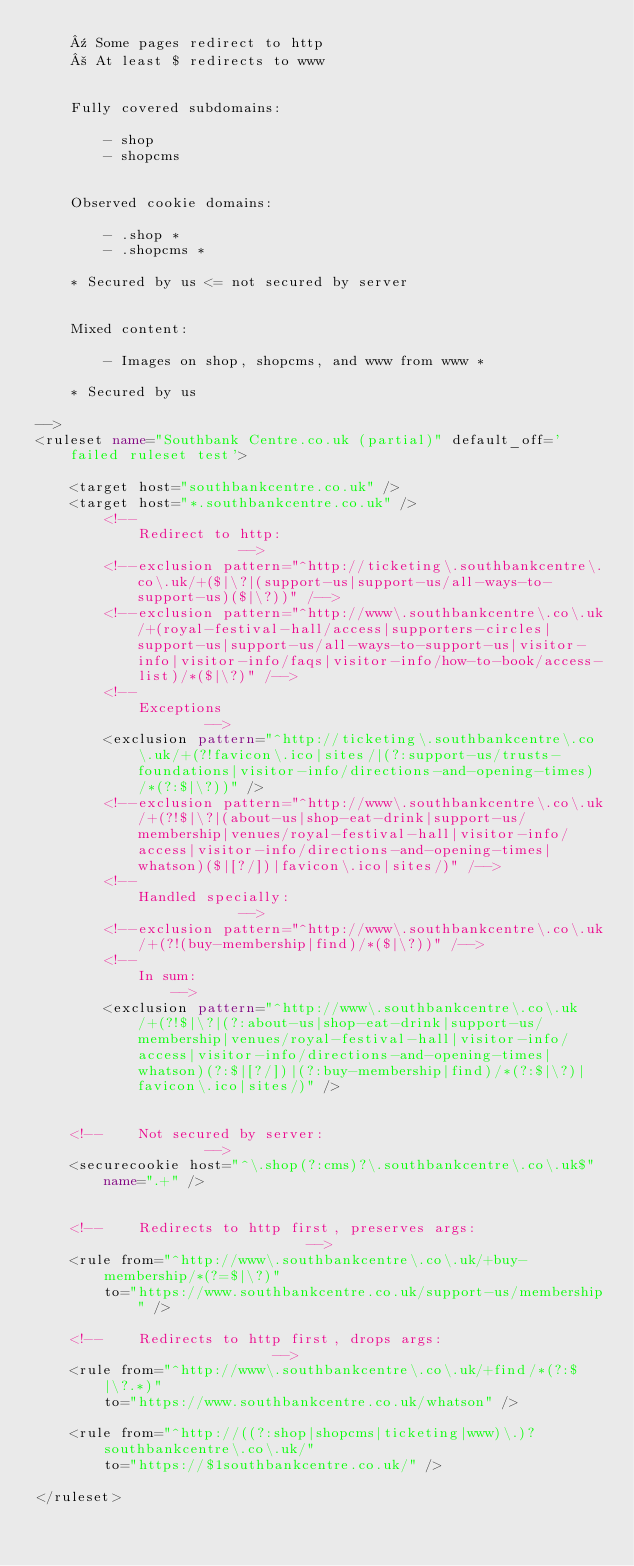Convert code to text. <code><loc_0><loc_0><loc_500><loc_500><_XML_>	¹ Some pages redirect to http
	² At least $ redirects to www


	Fully covered subdomains:

		- shop
		- shopcms


	Observed cookie domains:

		- .shop *
		- .shopcms *

	* Secured by us <= not secured by server


	Mixed content:

		- Images on shop, shopcms, and www from www *

	* Secured by us

-->
<ruleset name="Southbank Centre.co.uk (partial)" default_off='failed ruleset test'>

	<target host="southbankcentre.co.uk" />
	<target host="*.southbankcentre.co.uk" />
		<!--
			Redirect to http:
						-->
		<!--exclusion pattern="^http://ticketing\.southbankcentre\.co\.uk/+($|\?|(support-us|support-us/all-ways-to-support-us)($|\?))" /-->
		<!--exclusion pattern="^http://www\.southbankcentre\.co\.uk/+(royal-festival-hall/access|supporters-circles|support-us|support-us/all-ways-to-support-us|visitor-info|visitor-info/faqs|visitor-info/how-to-book/access-list)/*($|\?)" /-->
		<!--
			Exceptions
					-->
		<exclusion pattern="^http://ticketing\.southbankcentre\.co\.uk/+(?!favicon\.ico|sites/|(?:support-us/trusts-foundations|visitor-info/directions-and-opening-times)/*(?:$|\?))" />
		<!--exclusion pattern="^http://www\.southbankcentre\.co\.uk/+(?!$|\?|(about-us|shop-eat-drink|support-us/membership|venues/royal-festival-hall|visitor-info/access|visitor-info/directions-and-opening-times|whatson)($|[?/])|favicon\.ico|sites/)" /-->
		<!--
			Handled specially:
						-->
		<!--exclusion pattern="^http://www\.southbankcentre\.co\.uk/+(?!(buy-membership|find)/*($|\?))" /-->
		<!--
			In sum:
				-->
		<exclusion pattern="^http://www\.southbankcentre\.co\.uk/+(?!$|\?|(?:about-us|shop-eat-drink|support-us/membership|venues/royal-festival-hall|visitor-info/access|visitor-info/directions-and-opening-times|whatson)(?:$|[?/])|(?:buy-membership|find)/*(?:$|\?)|favicon\.ico|sites/)" />


	<!--	Not secured by server:
					-->
	<securecookie host="^\.shop(?:cms)?\.southbankcentre\.co\.uk$" name=".+" />


	<!--	Redirects to http first, preserves args:
								-->
	<rule from="^http://www\.southbankcentre\.co\.uk/+buy-membership/*(?=$|\?)"
		to="https://www.southbankcentre.co.uk/support-us/membership" />

	<!--	Redirects to http first, drops args:
							-->
	<rule from="^http://www\.southbankcentre\.co\.uk/+find/*(?:$|\?.*)"
		to="https://www.southbankcentre.co.uk/whatson" />

	<rule from="^http://((?:shop|shopcms|ticketing|www)\.)?southbankcentre\.co\.uk/"
		to="https://$1southbankcentre.co.uk/" />

</ruleset>
</code> 